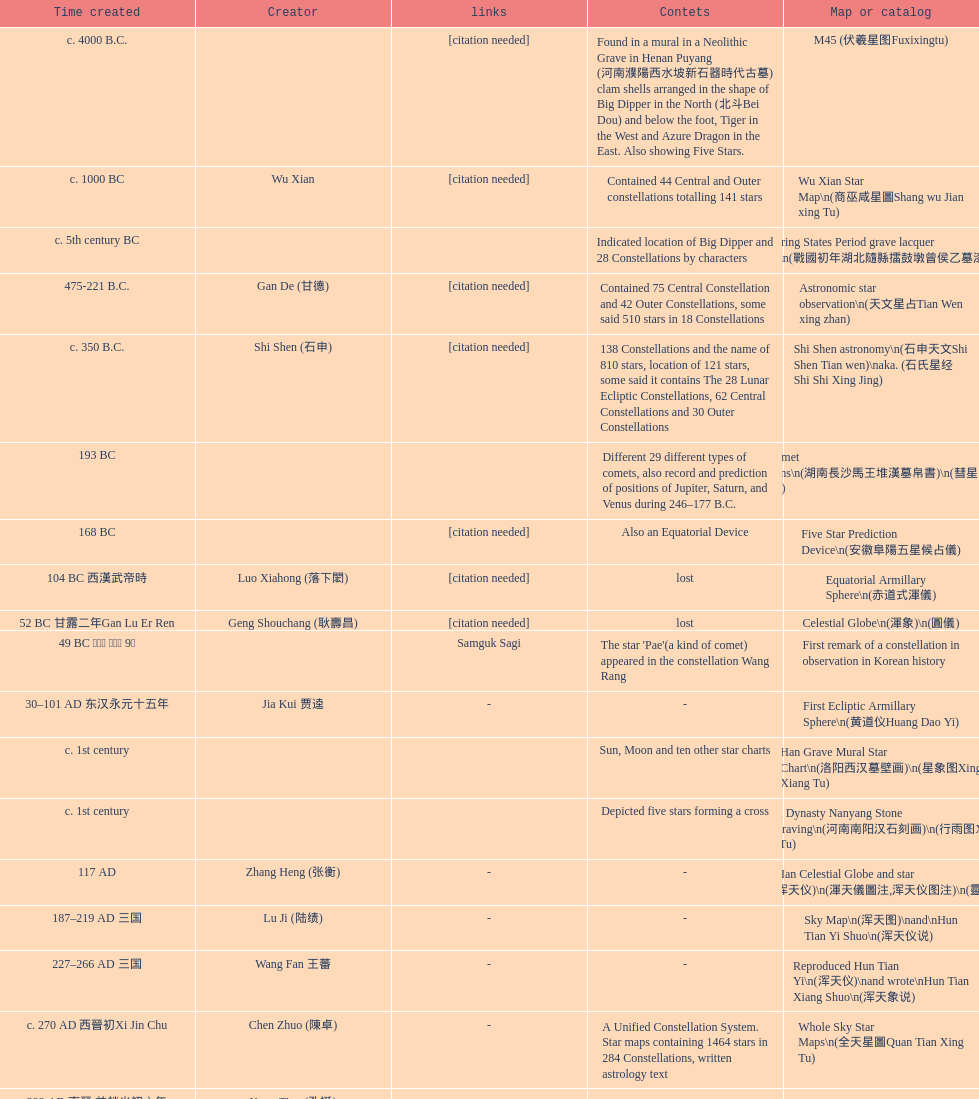What is the difference between the five star prediction device's date of creation and the han comet diagrams' date of creation? 25 years. 